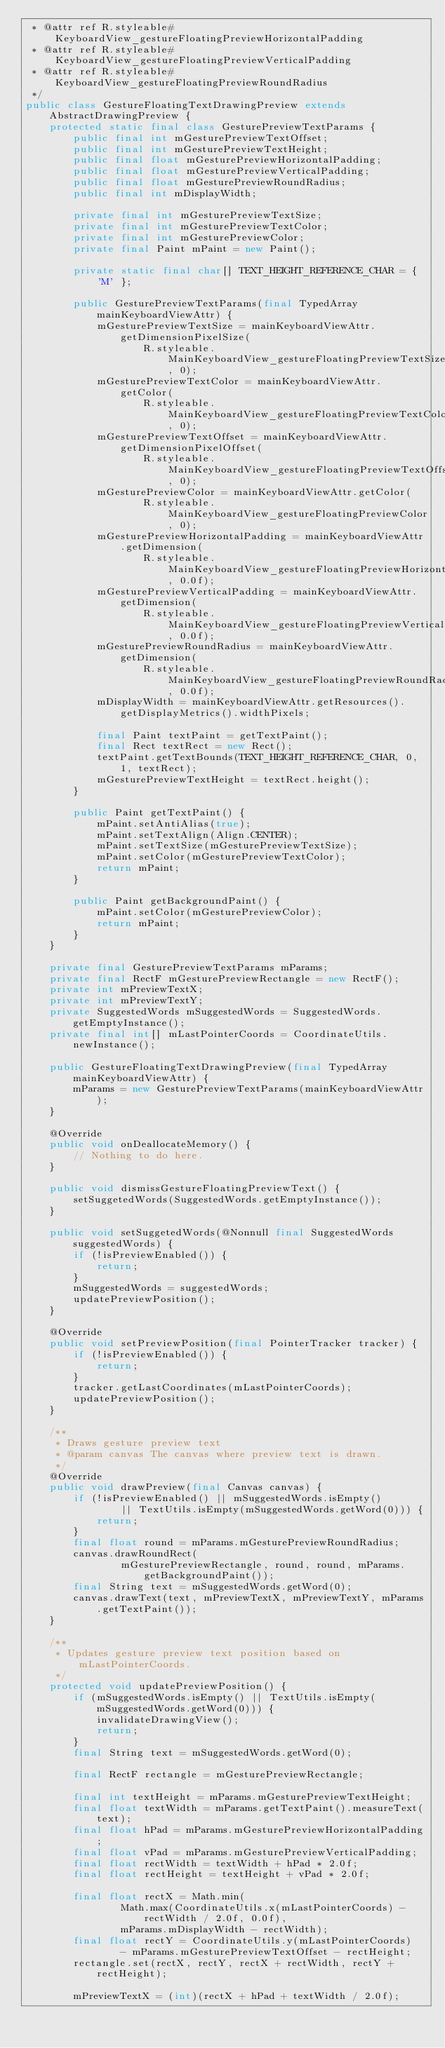Convert code to text. <code><loc_0><loc_0><loc_500><loc_500><_Java_> * @attr ref R.styleable#KeyboardView_gestureFloatingPreviewHorizontalPadding
 * @attr ref R.styleable#KeyboardView_gestureFloatingPreviewVerticalPadding
 * @attr ref R.styleable#KeyboardView_gestureFloatingPreviewRoundRadius
 */
public class GestureFloatingTextDrawingPreview extends AbstractDrawingPreview {
    protected static final class GesturePreviewTextParams {
        public final int mGesturePreviewTextOffset;
        public final int mGesturePreviewTextHeight;
        public final float mGesturePreviewHorizontalPadding;
        public final float mGesturePreviewVerticalPadding;
        public final float mGesturePreviewRoundRadius;
        public final int mDisplayWidth;

        private final int mGesturePreviewTextSize;
        private final int mGesturePreviewTextColor;
        private final int mGesturePreviewColor;
        private final Paint mPaint = new Paint();

        private static final char[] TEXT_HEIGHT_REFERENCE_CHAR = { 'M' };

        public GesturePreviewTextParams(final TypedArray mainKeyboardViewAttr) {
            mGesturePreviewTextSize = mainKeyboardViewAttr.getDimensionPixelSize(
                    R.styleable.MainKeyboardView_gestureFloatingPreviewTextSize, 0);
            mGesturePreviewTextColor = mainKeyboardViewAttr.getColor(
                    R.styleable.MainKeyboardView_gestureFloatingPreviewTextColor, 0);
            mGesturePreviewTextOffset = mainKeyboardViewAttr.getDimensionPixelOffset(
                    R.styleable.MainKeyboardView_gestureFloatingPreviewTextOffset, 0);
            mGesturePreviewColor = mainKeyboardViewAttr.getColor(
                    R.styleable.MainKeyboardView_gestureFloatingPreviewColor, 0);
            mGesturePreviewHorizontalPadding = mainKeyboardViewAttr.getDimension(
                    R.styleable.MainKeyboardView_gestureFloatingPreviewHorizontalPadding, 0.0f);
            mGesturePreviewVerticalPadding = mainKeyboardViewAttr.getDimension(
                    R.styleable.MainKeyboardView_gestureFloatingPreviewVerticalPadding, 0.0f);
            mGesturePreviewRoundRadius = mainKeyboardViewAttr.getDimension(
                    R.styleable.MainKeyboardView_gestureFloatingPreviewRoundRadius, 0.0f);
            mDisplayWidth = mainKeyboardViewAttr.getResources().getDisplayMetrics().widthPixels;

            final Paint textPaint = getTextPaint();
            final Rect textRect = new Rect();
            textPaint.getTextBounds(TEXT_HEIGHT_REFERENCE_CHAR, 0, 1, textRect);
            mGesturePreviewTextHeight = textRect.height();
        }

        public Paint getTextPaint() {
            mPaint.setAntiAlias(true);
            mPaint.setTextAlign(Align.CENTER);
            mPaint.setTextSize(mGesturePreviewTextSize);
            mPaint.setColor(mGesturePreviewTextColor);
            return mPaint;
        }

        public Paint getBackgroundPaint() {
            mPaint.setColor(mGesturePreviewColor);
            return mPaint;
        }
    }

    private final GesturePreviewTextParams mParams;
    private final RectF mGesturePreviewRectangle = new RectF();
    private int mPreviewTextX;
    private int mPreviewTextY;
    private SuggestedWords mSuggestedWords = SuggestedWords.getEmptyInstance();
    private final int[] mLastPointerCoords = CoordinateUtils.newInstance();

    public GestureFloatingTextDrawingPreview(final TypedArray mainKeyboardViewAttr) {
        mParams = new GesturePreviewTextParams(mainKeyboardViewAttr);
    }

    @Override
    public void onDeallocateMemory() {
        // Nothing to do here.
    }

    public void dismissGestureFloatingPreviewText() {
        setSuggetedWords(SuggestedWords.getEmptyInstance());
    }

    public void setSuggetedWords(@Nonnull final SuggestedWords suggestedWords) {
        if (!isPreviewEnabled()) {
            return;
        }
        mSuggestedWords = suggestedWords;
        updatePreviewPosition();
    }

    @Override
    public void setPreviewPosition(final PointerTracker tracker) {
        if (!isPreviewEnabled()) {
            return;
        }
        tracker.getLastCoordinates(mLastPointerCoords);
        updatePreviewPosition();
    }

    /**
     * Draws gesture preview text
     * @param canvas The canvas where preview text is drawn.
     */
    @Override
    public void drawPreview(final Canvas canvas) {
        if (!isPreviewEnabled() || mSuggestedWords.isEmpty()
                || TextUtils.isEmpty(mSuggestedWords.getWord(0))) {
            return;
        }
        final float round = mParams.mGesturePreviewRoundRadius;
        canvas.drawRoundRect(
                mGesturePreviewRectangle, round, round, mParams.getBackgroundPaint());
        final String text = mSuggestedWords.getWord(0);
        canvas.drawText(text, mPreviewTextX, mPreviewTextY, mParams.getTextPaint());
    }

    /**
     * Updates gesture preview text position based on mLastPointerCoords.
     */
    protected void updatePreviewPosition() {
        if (mSuggestedWords.isEmpty() || TextUtils.isEmpty(mSuggestedWords.getWord(0))) {
            invalidateDrawingView();
            return;
        }
        final String text = mSuggestedWords.getWord(0);

        final RectF rectangle = mGesturePreviewRectangle;

        final int textHeight = mParams.mGesturePreviewTextHeight;
        final float textWidth = mParams.getTextPaint().measureText(text);
        final float hPad = mParams.mGesturePreviewHorizontalPadding;
        final float vPad = mParams.mGesturePreviewVerticalPadding;
        final float rectWidth = textWidth + hPad * 2.0f;
        final float rectHeight = textHeight + vPad * 2.0f;

        final float rectX = Math.min(
                Math.max(CoordinateUtils.x(mLastPointerCoords) - rectWidth / 2.0f, 0.0f),
                mParams.mDisplayWidth - rectWidth);
        final float rectY = CoordinateUtils.y(mLastPointerCoords)
                - mParams.mGesturePreviewTextOffset - rectHeight;
        rectangle.set(rectX, rectY, rectX + rectWidth, rectY + rectHeight);

        mPreviewTextX = (int)(rectX + hPad + textWidth / 2.0f);</code> 